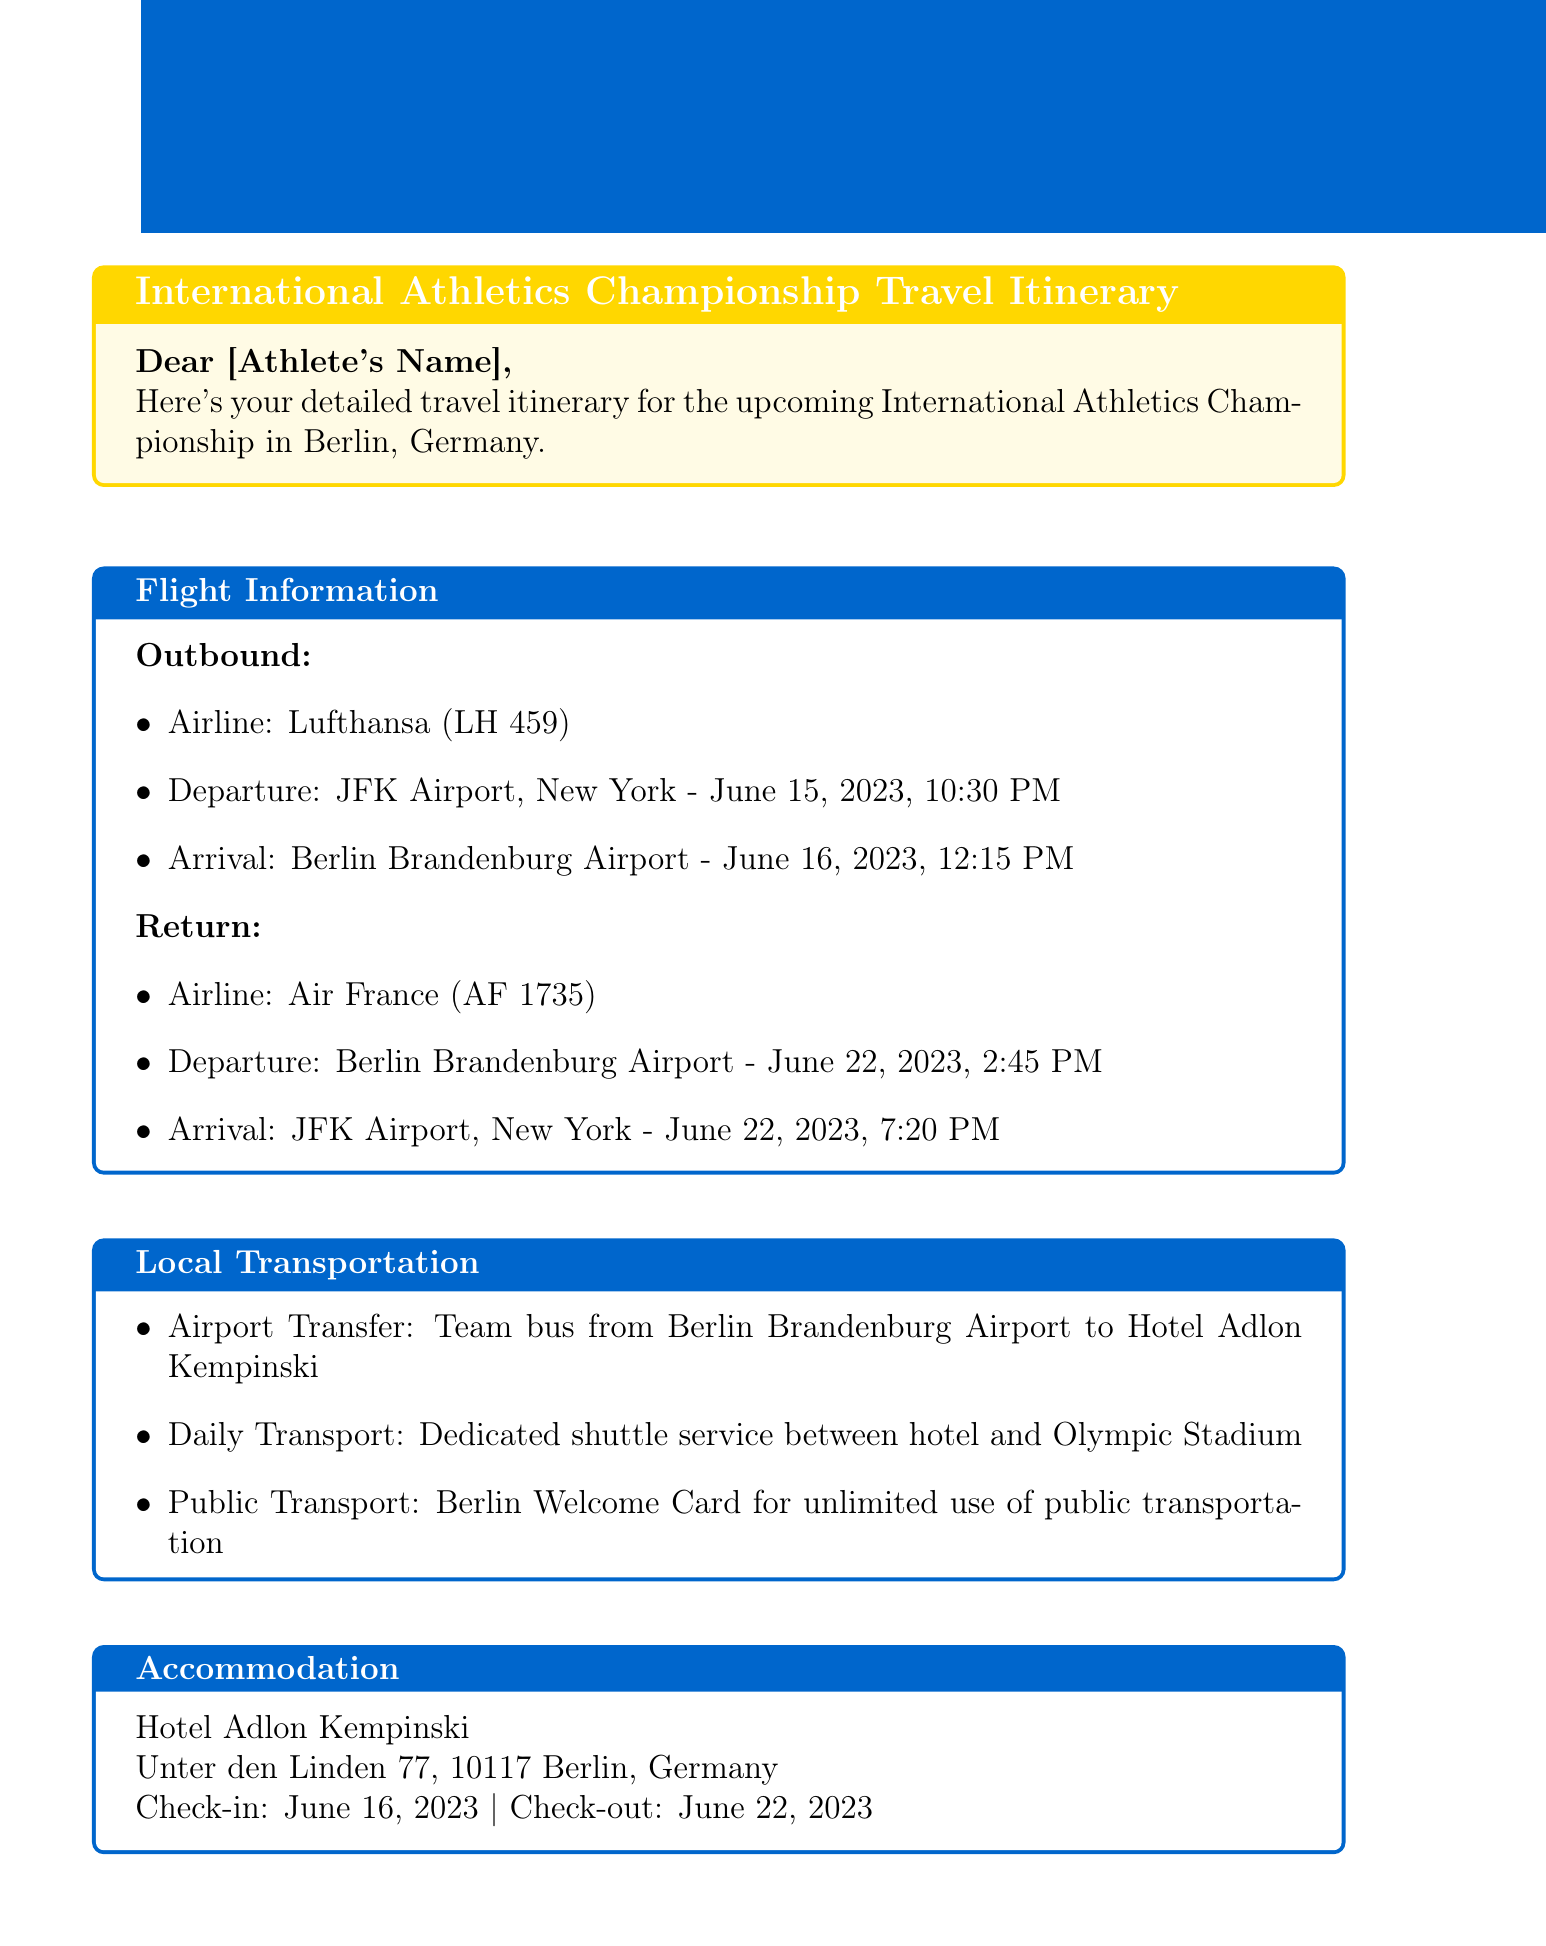What is the departure airport? The departure airport mentioned in the document is JFK Airport, New York.
Answer: JFK Airport, New York What is the check-in date at the hotel? The check-in date for the hotel is specified in the accommodation section.
Answer: June 16, 2023 Who is the team manager? The team manager's name is listed in the emergency contacts section of the document.
Answer: John Smith What airline is used for the return flight? The airline for the return flight is found in the flight information section.
Answer: Air France What are the competition dates? The competition dates are noted in the competition schedule section.
Answer: June 17-21, 2023 How will athletes get from the airport to the hotel? The document states the transportation method from the airport to the hotel.
Answer: Team bus What time is the athletes' briefing? The time for the athletes' briefing is mentioned in the competition schedule section.
Answer: 7:00 PM What is included in the public transport arrangement? The document specifies a transport arrangement mentioned in the local transportation section.
Answer: Berlin Welcome Card What is the address of the hotel? The hotel address is detailed in the accommodation section of the document.
Answer: Unter den Linden 77, 10117 Berlin, Germany 